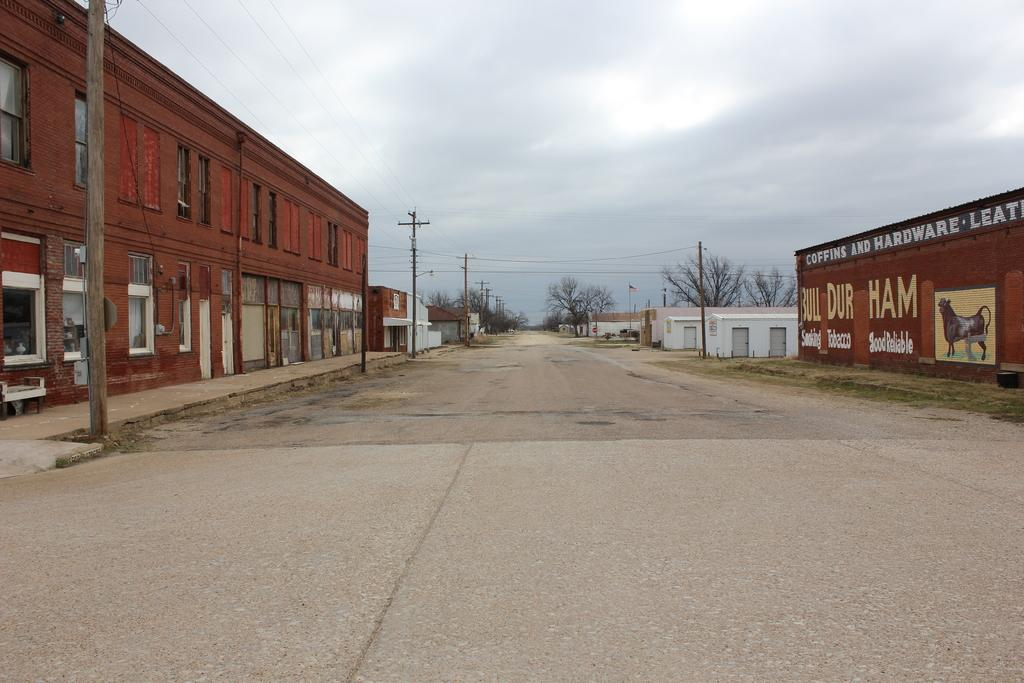What type of structures are visible in the image? There are houses in the image. What features do the houses have? The houses have windows and doors. What else can be seen in the image besides the houses? There are electric poles, wires, trees, images on the wall, and text on the wall in the image. What is visible in the sky in the image? The sky is visible in the image. Can you tell me how the houses produce electricity in the image? The houses themselves do not produce electricity in the image; the electric poles and wires are responsible for that. What type of operation is being performed by the trees in the image? The trees are not performing any operation in the image; they are simply standing and providing a natural element to the scene. 